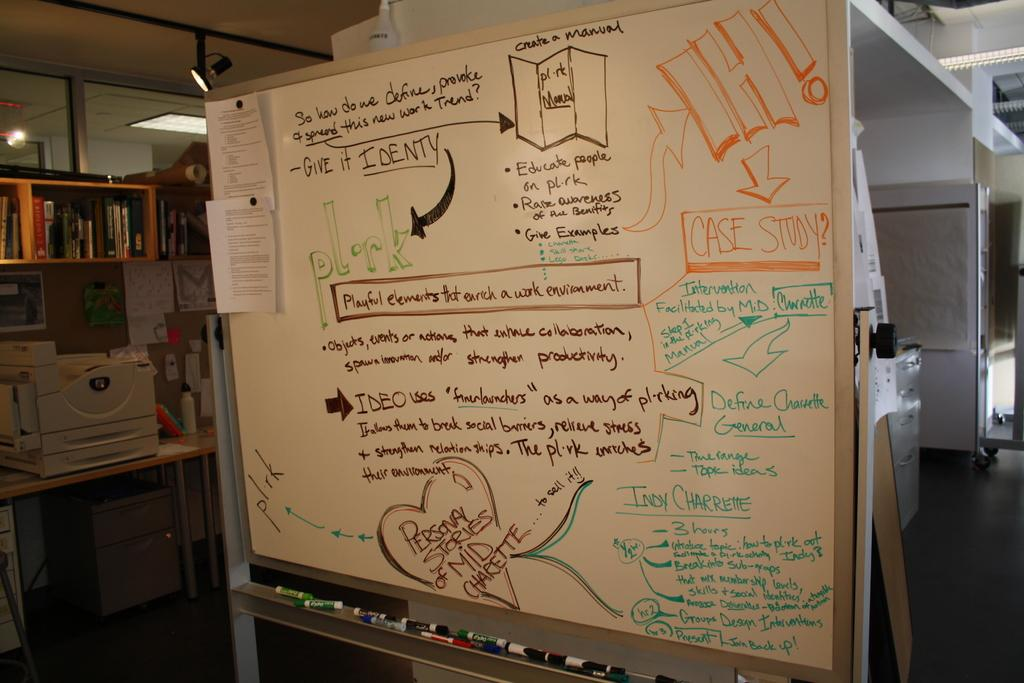<image>
Share a concise interpretation of the image provided. Whiteboard which has a box which says "Case Study". 